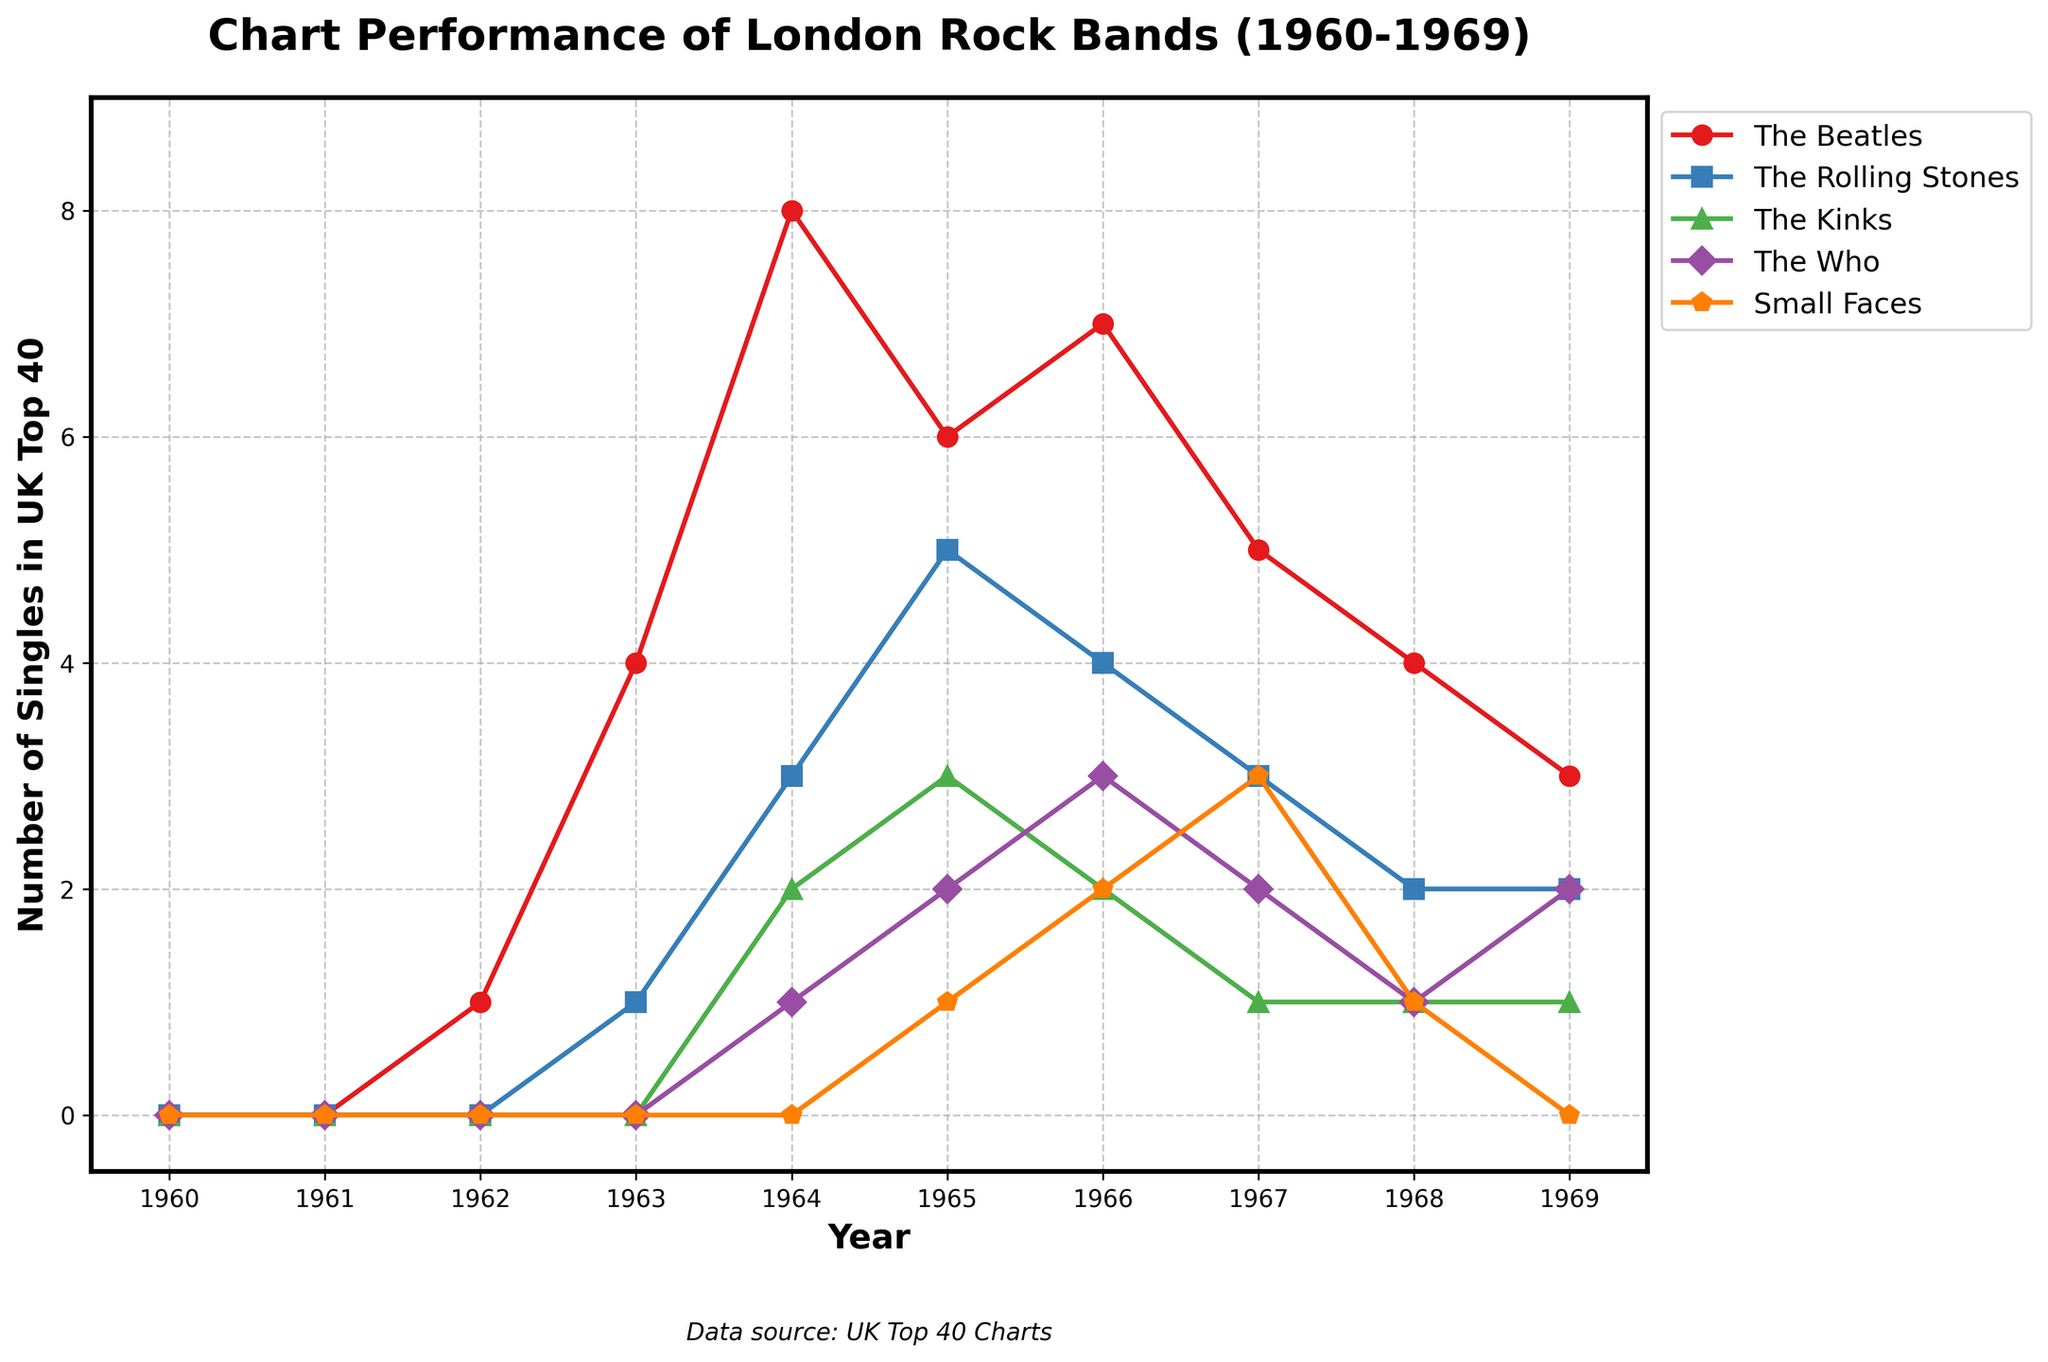Which band had the highest number of singles in the UK Top 40 in 1964? By looking at the figure and focusing on the year 1964, identify which band's line reaches the highest point. The Beatles' line hits 8 singles in 1964.
Answer: The Beatles How many more singles did The Rolling Stones have than The Who in 1965? In 1965, The Rolling Stones had 5 singles and The Who had 2 singles. The difference is 5 - 2 = 3 singles.
Answer: 3 singles Which year did The Kinks have their peak performance on the UK Top 40? Look for the highest point in The Kinks' line. In 1965, The Kinks hit their peak with 3 singles.
Answer: 1965 Compare the number of singles The Small Faces had in 1968 and 1969. Which year was higher? The figure shows The Small Faces with 1 single in 1968 and 0 singles in 1969. Therefore, they had more singles in 1968.
Answer: 1968 What is the average number of singles The Beatles had in the UK Top 40 from 1964 to 1967? Summing The Beatles' singles from 1964 to 1967: 8 (1964) + 6 (1965) + 7 (1966) + 5 (1967) = 26 singles. The average is 26 / 4 years = 6.5 singles per year.
Answer: 6.5 singles per year In which years did The Who surpass The Kinks in the UK Top 40 singles? Compare their lines year by year. In 1964, The Who (1) did not surpass The Kinks (2); in 1965, The Who (2) did not surpass The Kinks (3); in 1966, The Who (3) surpassed The Kinks (2); in 1967, The Who (2) surpassed The Kinks (1); in 1969, The Who (2) again surpassed The Kinks (1). So the years are 1966, 1967, and 1969.
Answer: 1966, 1967, 1969 Which band showed a consistent presence on the UK Top 40 from 1965 to 1969 without ever having 0 singles? Checking each band's line from 1965 to 1969: The Beatles, The Rolling Stones, and The Who all have consistent non-zero presence. The Kinks and The Small Faces have at least one year with 0 singles post 1965.
Answer: The Beatles, The Rolling Stones, The Who What was the total number of singles The Rolling Stones had in the UK Top 40 from 1962 to 1969? Adding The Rolling Stones' singles from 1962 to 1969: 0 (1962) + 1 (1963) + 3 (1964) + 5 (1965) + 4 (1966) + 3 (1967) + 2 (1968) + 2 (1969) = 20 singles.
Answer: 20 singles How many singles did both The Beatles and The Rolling Stones have combined in 1965? In 1965, The Beatles had 6 singles and The Rolling Stones had 5 singles. Combined, they had 6 + 5 = 11 singles.
Answer: 11 singles What is the trend observed for The Small Faces’ UK Top 40 singles from 1965 to 1969? The Small Faces' line shows an increase from 1 single in 1965, reaching a peak of 3 in 1967, then decreasing to 1 in 1968 and 0 in 1969.
Answer: Increase to peak in 1967, then decline 